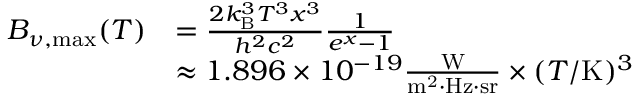<formula> <loc_0><loc_0><loc_500><loc_500>{ \begin{array} { r l } { B _ { \nu , { \max } } ( T ) } & { = { \frac { 2 k _ { B } ^ { 3 } T ^ { 3 } x ^ { 3 } } { h ^ { 2 } c ^ { 2 } } } { \frac { 1 } { e ^ { x } - 1 } } } \\ & { \approx 1 . 8 9 6 \times 1 0 ^ { - 1 9 } { \frac { W } { m ^ { 2 } \cdot H z \cdot s r } } \times ( T / K ) ^ { 3 } } \end{array} }</formula> 